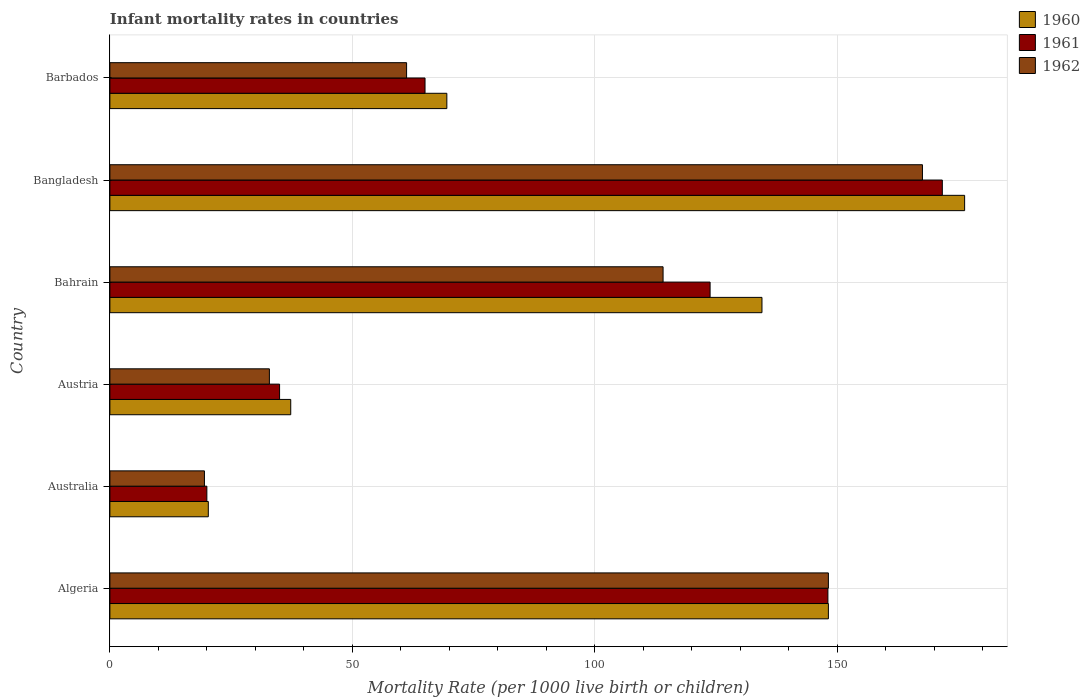Are the number of bars on each tick of the Y-axis equal?
Keep it short and to the point. Yes. What is the label of the 3rd group of bars from the top?
Offer a very short reply. Bahrain. What is the infant mortality rate in 1962 in Austria?
Your answer should be compact. 32.9. Across all countries, what is the maximum infant mortality rate in 1962?
Offer a terse response. 167.6. In which country was the infant mortality rate in 1960 minimum?
Your answer should be compact. Australia. What is the total infant mortality rate in 1960 in the graph?
Provide a succinct answer. 586.1. What is the difference between the infant mortality rate in 1960 in Algeria and that in Bangladesh?
Your answer should be very brief. -28.1. What is the difference between the infant mortality rate in 1962 in Barbados and the infant mortality rate in 1961 in Australia?
Give a very brief answer. 41.2. What is the average infant mortality rate in 1962 per country?
Provide a short and direct response. 90.58. What is the difference between the infant mortality rate in 1960 and infant mortality rate in 1961 in Austria?
Make the answer very short. 2.3. What is the ratio of the infant mortality rate in 1960 in Australia to that in Barbados?
Your answer should be very brief. 0.29. What is the difference between the highest and the second highest infant mortality rate in 1961?
Provide a short and direct response. 23.6. What is the difference between the highest and the lowest infant mortality rate in 1962?
Your response must be concise. 148.1. Is the sum of the infant mortality rate in 1960 in Algeria and Barbados greater than the maximum infant mortality rate in 1961 across all countries?
Your response must be concise. Yes. What does the 1st bar from the top in Bangladesh represents?
Offer a terse response. 1962. Is it the case that in every country, the sum of the infant mortality rate in 1961 and infant mortality rate in 1960 is greater than the infant mortality rate in 1962?
Make the answer very short. Yes. What is the difference between two consecutive major ticks on the X-axis?
Make the answer very short. 50. Are the values on the major ticks of X-axis written in scientific E-notation?
Keep it short and to the point. No. Does the graph contain any zero values?
Offer a very short reply. No. Does the graph contain grids?
Your answer should be very brief. Yes. How are the legend labels stacked?
Make the answer very short. Vertical. What is the title of the graph?
Your answer should be very brief. Infant mortality rates in countries. What is the label or title of the X-axis?
Your response must be concise. Mortality Rate (per 1000 live birth or children). What is the Mortality Rate (per 1000 live birth or children) in 1960 in Algeria?
Your answer should be very brief. 148.2. What is the Mortality Rate (per 1000 live birth or children) in 1961 in Algeria?
Your response must be concise. 148.1. What is the Mortality Rate (per 1000 live birth or children) of 1962 in Algeria?
Your answer should be very brief. 148.2. What is the Mortality Rate (per 1000 live birth or children) of 1960 in Australia?
Offer a very short reply. 20.3. What is the Mortality Rate (per 1000 live birth or children) in 1961 in Australia?
Your answer should be very brief. 20. What is the Mortality Rate (per 1000 live birth or children) of 1962 in Australia?
Provide a succinct answer. 19.5. What is the Mortality Rate (per 1000 live birth or children) in 1960 in Austria?
Offer a terse response. 37.3. What is the Mortality Rate (per 1000 live birth or children) in 1961 in Austria?
Keep it short and to the point. 35. What is the Mortality Rate (per 1000 live birth or children) in 1962 in Austria?
Provide a succinct answer. 32.9. What is the Mortality Rate (per 1000 live birth or children) of 1960 in Bahrain?
Offer a terse response. 134.5. What is the Mortality Rate (per 1000 live birth or children) of 1961 in Bahrain?
Offer a terse response. 123.8. What is the Mortality Rate (per 1000 live birth or children) of 1962 in Bahrain?
Provide a succinct answer. 114.1. What is the Mortality Rate (per 1000 live birth or children) of 1960 in Bangladesh?
Provide a succinct answer. 176.3. What is the Mortality Rate (per 1000 live birth or children) of 1961 in Bangladesh?
Keep it short and to the point. 171.7. What is the Mortality Rate (per 1000 live birth or children) of 1962 in Bangladesh?
Make the answer very short. 167.6. What is the Mortality Rate (per 1000 live birth or children) in 1960 in Barbados?
Keep it short and to the point. 69.5. What is the Mortality Rate (per 1000 live birth or children) of 1961 in Barbados?
Your answer should be compact. 65. What is the Mortality Rate (per 1000 live birth or children) in 1962 in Barbados?
Provide a succinct answer. 61.2. Across all countries, what is the maximum Mortality Rate (per 1000 live birth or children) in 1960?
Make the answer very short. 176.3. Across all countries, what is the maximum Mortality Rate (per 1000 live birth or children) of 1961?
Your answer should be very brief. 171.7. Across all countries, what is the maximum Mortality Rate (per 1000 live birth or children) in 1962?
Provide a short and direct response. 167.6. Across all countries, what is the minimum Mortality Rate (per 1000 live birth or children) of 1960?
Your response must be concise. 20.3. Across all countries, what is the minimum Mortality Rate (per 1000 live birth or children) in 1961?
Provide a succinct answer. 20. Across all countries, what is the minimum Mortality Rate (per 1000 live birth or children) of 1962?
Offer a very short reply. 19.5. What is the total Mortality Rate (per 1000 live birth or children) in 1960 in the graph?
Offer a terse response. 586.1. What is the total Mortality Rate (per 1000 live birth or children) of 1961 in the graph?
Offer a very short reply. 563.6. What is the total Mortality Rate (per 1000 live birth or children) in 1962 in the graph?
Your answer should be very brief. 543.5. What is the difference between the Mortality Rate (per 1000 live birth or children) of 1960 in Algeria and that in Australia?
Your answer should be compact. 127.9. What is the difference between the Mortality Rate (per 1000 live birth or children) in 1961 in Algeria and that in Australia?
Provide a short and direct response. 128.1. What is the difference between the Mortality Rate (per 1000 live birth or children) in 1962 in Algeria and that in Australia?
Make the answer very short. 128.7. What is the difference between the Mortality Rate (per 1000 live birth or children) in 1960 in Algeria and that in Austria?
Provide a short and direct response. 110.9. What is the difference between the Mortality Rate (per 1000 live birth or children) in 1961 in Algeria and that in Austria?
Your response must be concise. 113.1. What is the difference between the Mortality Rate (per 1000 live birth or children) in 1962 in Algeria and that in Austria?
Your response must be concise. 115.3. What is the difference between the Mortality Rate (per 1000 live birth or children) of 1961 in Algeria and that in Bahrain?
Your answer should be very brief. 24.3. What is the difference between the Mortality Rate (per 1000 live birth or children) of 1962 in Algeria and that in Bahrain?
Keep it short and to the point. 34.1. What is the difference between the Mortality Rate (per 1000 live birth or children) in 1960 in Algeria and that in Bangladesh?
Provide a succinct answer. -28.1. What is the difference between the Mortality Rate (per 1000 live birth or children) of 1961 in Algeria and that in Bangladesh?
Your answer should be compact. -23.6. What is the difference between the Mortality Rate (per 1000 live birth or children) in 1962 in Algeria and that in Bangladesh?
Ensure brevity in your answer.  -19.4. What is the difference between the Mortality Rate (per 1000 live birth or children) of 1960 in Algeria and that in Barbados?
Make the answer very short. 78.7. What is the difference between the Mortality Rate (per 1000 live birth or children) of 1961 in Algeria and that in Barbados?
Provide a succinct answer. 83.1. What is the difference between the Mortality Rate (per 1000 live birth or children) of 1962 in Australia and that in Austria?
Make the answer very short. -13.4. What is the difference between the Mortality Rate (per 1000 live birth or children) of 1960 in Australia and that in Bahrain?
Ensure brevity in your answer.  -114.2. What is the difference between the Mortality Rate (per 1000 live birth or children) in 1961 in Australia and that in Bahrain?
Ensure brevity in your answer.  -103.8. What is the difference between the Mortality Rate (per 1000 live birth or children) in 1962 in Australia and that in Bahrain?
Make the answer very short. -94.6. What is the difference between the Mortality Rate (per 1000 live birth or children) of 1960 in Australia and that in Bangladesh?
Offer a very short reply. -156. What is the difference between the Mortality Rate (per 1000 live birth or children) of 1961 in Australia and that in Bangladesh?
Ensure brevity in your answer.  -151.7. What is the difference between the Mortality Rate (per 1000 live birth or children) of 1962 in Australia and that in Bangladesh?
Provide a short and direct response. -148.1. What is the difference between the Mortality Rate (per 1000 live birth or children) of 1960 in Australia and that in Barbados?
Provide a succinct answer. -49.2. What is the difference between the Mortality Rate (per 1000 live birth or children) of 1961 in Australia and that in Barbados?
Give a very brief answer. -45. What is the difference between the Mortality Rate (per 1000 live birth or children) in 1962 in Australia and that in Barbados?
Provide a succinct answer. -41.7. What is the difference between the Mortality Rate (per 1000 live birth or children) in 1960 in Austria and that in Bahrain?
Your answer should be very brief. -97.2. What is the difference between the Mortality Rate (per 1000 live birth or children) in 1961 in Austria and that in Bahrain?
Your response must be concise. -88.8. What is the difference between the Mortality Rate (per 1000 live birth or children) of 1962 in Austria and that in Bahrain?
Make the answer very short. -81.2. What is the difference between the Mortality Rate (per 1000 live birth or children) of 1960 in Austria and that in Bangladesh?
Offer a terse response. -139. What is the difference between the Mortality Rate (per 1000 live birth or children) in 1961 in Austria and that in Bangladesh?
Provide a short and direct response. -136.7. What is the difference between the Mortality Rate (per 1000 live birth or children) of 1962 in Austria and that in Bangladesh?
Provide a short and direct response. -134.7. What is the difference between the Mortality Rate (per 1000 live birth or children) in 1960 in Austria and that in Barbados?
Your answer should be very brief. -32.2. What is the difference between the Mortality Rate (per 1000 live birth or children) of 1962 in Austria and that in Barbados?
Your answer should be very brief. -28.3. What is the difference between the Mortality Rate (per 1000 live birth or children) in 1960 in Bahrain and that in Bangladesh?
Make the answer very short. -41.8. What is the difference between the Mortality Rate (per 1000 live birth or children) in 1961 in Bahrain and that in Bangladesh?
Keep it short and to the point. -47.9. What is the difference between the Mortality Rate (per 1000 live birth or children) in 1962 in Bahrain and that in Bangladesh?
Ensure brevity in your answer.  -53.5. What is the difference between the Mortality Rate (per 1000 live birth or children) of 1960 in Bahrain and that in Barbados?
Your answer should be compact. 65. What is the difference between the Mortality Rate (per 1000 live birth or children) of 1961 in Bahrain and that in Barbados?
Your answer should be compact. 58.8. What is the difference between the Mortality Rate (per 1000 live birth or children) in 1962 in Bahrain and that in Barbados?
Your response must be concise. 52.9. What is the difference between the Mortality Rate (per 1000 live birth or children) in 1960 in Bangladesh and that in Barbados?
Your response must be concise. 106.8. What is the difference between the Mortality Rate (per 1000 live birth or children) of 1961 in Bangladesh and that in Barbados?
Provide a succinct answer. 106.7. What is the difference between the Mortality Rate (per 1000 live birth or children) of 1962 in Bangladesh and that in Barbados?
Your answer should be very brief. 106.4. What is the difference between the Mortality Rate (per 1000 live birth or children) in 1960 in Algeria and the Mortality Rate (per 1000 live birth or children) in 1961 in Australia?
Provide a short and direct response. 128.2. What is the difference between the Mortality Rate (per 1000 live birth or children) of 1960 in Algeria and the Mortality Rate (per 1000 live birth or children) of 1962 in Australia?
Your answer should be compact. 128.7. What is the difference between the Mortality Rate (per 1000 live birth or children) in 1961 in Algeria and the Mortality Rate (per 1000 live birth or children) in 1962 in Australia?
Give a very brief answer. 128.6. What is the difference between the Mortality Rate (per 1000 live birth or children) in 1960 in Algeria and the Mortality Rate (per 1000 live birth or children) in 1961 in Austria?
Make the answer very short. 113.2. What is the difference between the Mortality Rate (per 1000 live birth or children) in 1960 in Algeria and the Mortality Rate (per 1000 live birth or children) in 1962 in Austria?
Make the answer very short. 115.3. What is the difference between the Mortality Rate (per 1000 live birth or children) in 1961 in Algeria and the Mortality Rate (per 1000 live birth or children) in 1962 in Austria?
Make the answer very short. 115.2. What is the difference between the Mortality Rate (per 1000 live birth or children) in 1960 in Algeria and the Mortality Rate (per 1000 live birth or children) in 1961 in Bahrain?
Offer a very short reply. 24.4. What is the difference between the Mortality Rate (per 1000 live birth or children) in 1960 in Algeria and the Mortality Rate (per 1000 live birth or children) in 1962 in Bahrain?
Offer a terse response. 34.1. What is the difference between the Mortality Rate (per 1000 live birth or children) of 1960 in Algeria and the Mortality Rate (per 1000 live birth or children) of 1961 in Bangladesh?
Your answer should be very brief. -23.5. What is the difference between the Mortality Rate (per 1000 live birth or children) in 1960 in Algeria and the Mortality Rate (per 1000 live birth or children) in 1962 in Bangladesh?
Make the answer very short. -19.4. What is the difference between the Mortality Rate (per 1000 live birth or children) of 1961 in Algeria and the Mortality Rate (per 1000 live birth or children) of 1962 in Bangladesh?
Your response must be concise. -19.5. What is the difference between the Mortality Rate (per 1000 live birth or children) in 1960 in Algeria and the Mortality Rate (per 1000 live birth or children) in 1961 in Barbados?
Give a very brief answer. 83.2. What is the difference between the Mortality Rate (per 1000 live birth or children) in 1961 in Algeria and the Mortality Rate (per 1000 live birth or children) in 1962 in Barbados?
Offer a very short reply. 86.9. What is the difference between the Mortality Rate (per 1000 live birth or children) of 1960 in Australia and the Mortality Rate (per 1000 live birth or children) of 1961 in Austria?
Make the answer very short. -14.7. What is the difference between the Mortality Rate (per 1000 live birth or children) of 1960 in Australia and the Mortality Rate (per 1000 live birth or children) of 1962 in Austria?
Provide a succinct answer. -12.6. What is the difference between the Mortality Rate (per 1000 live birth or children) in 1960 in Australia and the Mortality Rate (per 1000 live birth or children) in 1961 in Bahrain?
Your response must be concise. -103.5. What is the difference between the Mortality Rate (per 1000 live birth or children) in 1960 in Australia and the Mortality Rate (per 1000 live birth or children) in 1962 in Bahrain?
Your answer should be very brief. -93.8. What is the difference between the Mortality Rate (per 1000 live birth or children) in 1961 in Australia and the Mortality Rate (per 1000 live birth or children) in 1962 in Bahrain?
Ensure brevity in your answer.  -94.1. What is the difference between the Mortality Rate (per 1000 live birth or children) of 1960 in Australia and the Mortality Rate (per 1000 live birth or children) of 1961 in Bangladesh?
Your response must be concise. -151.4. What is the difference between the Mortality Rate (per 1000 live birth or children) of 1960 in Australia and the Mortality Rate (per 1000 live birth or children) of 1962 in Bangladesh?
Ensure brevity in your answer.  -147.3. What is the difference between the Mortality Rate (per 1000 live birth or children) in 1961 in Australia and the Mortality Rate (per 1000 live birth or children) in 1962 in Bangladesh?
Your answer should be very brief. -147.6. What is the difference between the Mortality Rate (per 1000 live birth or children) of 1960 in Australia and the Mortality Rate (per 1000 live birth or children) of 1961 in Barbados?
Your answer should be compact. -44.7. What is the difference between the Mortality Rate (per 1000 live birth or children) of 1960 in Australia and the Mortality Rate (per 1000 live birth or children) of 1962 in Barbados?
Ensure brevity in your answer.  -40.9. What is the difference between the Mortality Rate (per 1000 live birth or children) in 1961 in Australia and the Mortality Rate (per 1000 live birth or children) in 1962 in Barbados?
Your answer should be compact. -41.2. What is the difference between the Mortality Rate (per 1000 live birth or children) in 1960 in Austria and the Mortality Rate (per 1000 live birth or children) in 1961 in Bahrain?
Offer a very short reply. -86.5. What is the difference between the Mortality Rate (per 1000 live birth or children) of 1960 in Austria and the Mortality Rate (per 1000 live birth or children) of 1962 in Bahrain?
Offer a terse response. -76.8. What is the difference between the Mortality Rate (per 1000 live birth or children) of 1961 in Austria and the Mortality Rate (per 1000 live birth or children) of 1962 in Bahrain?
Give a very brief answer. -79.1. What is the difference between the Mortality Rate (per 1000 live birth or children) in 1960 in Austria and the Mortality Rate (per 1000 live birth or children) in 1961 in Bangladesh?
Offer a terse response. -134.4. What is the difference between the Mortality Rate (per 1000 live birth or children) of 1960 in Austria and the Mortality Rate (per 1000 live birth or children) of 1962 in Bangladesh?
Ensure brevity in your answer.  -130.3. What is the difference between the Mortality Rate (per 1000 live birth or children) in 1961 in Austria and the Mortality Rate (per 1000 live birth or children) in 1962 in Bangladesh?
Give a very brief answer. -132.6. What is the difference between the Mortality Rate (per 1000 live birth or children) in 1960 in Austria and the Mortality Rate (per 1000 live birth or children) in 1961 in Barbados?
Make the answer very short. -27.7. What is the difference between the Mortality Rate (per 1000 live birth or children) in 1960 in Austria and the Mortality Rate (per 1000 live birth or children) in 1962 in Barbados?
Your answer should be very brief. -23.9. What is the difference between the Mortality Rate (per 1000 live birth or children) of 1961 in Austria and the Mortality Rate (per 1000 live birth or children) of 1962 in Barbados?
Ensure brevity in your answer.  -26.2. What is the difference between the Mortality Rate (per 1000 live birth or children) of 1960 in Bahrain and the Mortality Rate (per 1000 live birth or children) of 1961 in Bangladesh?
Ensure brevity in your answer.  -37.2. What is the difference between the Mortality Rate (per 1000 live birth or children) in 1960 in Bahrain and the Mortality Rate (per 1000 live birth or children) in 1962 in Bangladesh?
Your answer should be compact. -33.1. What is the difference between the Mortality Rate (per 1000 live birth or children) in 1961 in Bahrain and the Mortality Rate (per 1000 live birth or children) in 1962 in Bangladesh?
Offer a terse response. -43.8. What is the difference between the Mortality Rate (per 1000 live birth or children) in 1960 in Bahrain and the Mortality Rate (per 1000 live birth or children) in 1961 in Barbados?
Give a very brief answer. 69.5. What is the difference between the Mortality Rate (per 1000 live birth or children) in 1960 in Bahrain and the Mortality Rate (per 1000 live birth or children) in 1962 in Barbados?
Offer a very short reply. 73.3. What is the difference between the Mortality Rate (per 1000 live birth or children) of 1961 in Bahrain and the Mortality Rate (per 1000 live birth or children) of 1962 in Barbados?
Offer a very short reply. 62.6. What is the difference between the Mortality Rate (per 1000 live birth or children) in 1960 in Bangladesh and the Mortality Rate (per 1000 live birth or children) in 1961 in Barbados?
Give a very brief answer. 111.3. What is the difference between the Mortality Rate (per 1000 live birth or children) of 1960 in Bangladesh and the Mortality Rate (per 1000 live birth or children) of 1962 in Barbados?
Make the answer very short. 115.1. What is the difference between the Mortality Rate (per 1000 live birth or children) in 1961 in Bangladesh and the Mortality Rate (per 1000 live birth or children) in 1962 in Barbados?
Your answer should be very brief. 110.5. What is the average Mortality Rate (per 1000 live birth or children) in 1960 per country?
Provide a short and direct response. 97.68. What is the average Mortality Rate (per 1000 live birth or children) in 1961 per country?
Make the answer very short. 93.93. What is the average Mortality Rate (per 1000 live birth or children) of 1962 per country?
Keep it short and to the point. 90.58. What is the difference between the Mortality Rate (per 1000 live birth or children) in 1960 and Mortality Rate (per 1000 live birth or children) in 1961 in Algeria?
Provide a short and direct response. 0.1. What is the difference between the Mortality Rate (per 1000 live birth or children) in 1960 and Mortality Rate (per 1000 live birth or children) in 1962 in Algeria?
Your answer should be very brief. 0. What is the difference between the Mortality Rate (per 1000 live birth or children) in 1960 and Mortality Rate (per 1000 live birth or children) in 1961 in Australia?
Give a very brief answer. 0.3. What is the difference between the Mortality Rate (per 1000 live birth or children) in 1960 and Mortality Rate (per 1000 live birth or children) in 1962 in Australia?
Ensure brevity in your answer.  0.8. What is the difference between the Mortality Rate (per 1000 live birth or children) of 1960 and Mortality Rate (per 1000 live birth or children) of 1961 in Austria?
Provide a succinct answer. 2.3. What is the difference between the Mortality Rate (per 1000 live birth or children) of 1961 and Mortality Rate (per 1000 live birth or children) of 1962 in Austria?
Offer a terse response. 2.1. What is the difference between the Mortality Rate (per 1000 live birth or children) of 1960 and Mortality Rate (per 1000 live birth or children) of 1962 in Bahrain?
Provide a short and direct response. 20.4. What is the difference between the Mortality Rate (per 1000 live birth or children) in 1960 and Mortality Rate (per 1000 live birth or children) in 1961 in Bangladesh?
Provide a succinct answer. 4.6. What is the difference between the Mortality Rate (per 1000 live birth or children) of 1960 and Mortality Rate (per 1000 live birth or children) of 1962 in Bangladesh?
Offer a terse response. 8.7. What is the difference between the Mortality Rate (per 1000 live birth or children) of 1960 and Mortality Rate (per 1000 live birth or children) of 1962 in Barbados?
Your answer should be very brief. 8.3. What is the ratio of the Mortality Rate (per 1000 live birth or children) in 1960 in Algeria to that in Australia?
Your response must be concise. 7.3. What is the ratio of the Mortality Rate (per 1000 live birth or children) in 1961 in Algeria to that in Australia?
Give a very brief answer. 7.41. What is the ratio of the Mortality Rate (per 1000 live birth or children) of 1960 in Algeria to that in Austria?
Your answer should be very brief. 3.97. What is the ratio of the Mortality Rate (per 1000 live birth or children) of 1961 in Algeria to that in Austria?
Make the answer very short. 4.23. What is the ratio of the Mortality Rate (per 1000 live birth or children) in 1962 in Algeria to that in Austria?
Keep it short and to the point. 4.5. What is the ratio of the Mortality Rate (per 1000 live birth or children) of 1960 in Algeria to that in Bahrain?
Provide a short and direct response. 1.1. What is the ratio of the Mortality Rate (per 1000 live birth or children) in 1961 in Algeria to that in Bahrain?
Provide a short and direct response. 1.2. What is the ratio of the Mortality Rate (per 1000 live birth or children) of 1962 in Algeria to that in Bahrain?
Ensure brevity in your answer.  1.3. What is the ratio of the Mortality Rate (per 1000 live birth or children) in 1960 in Algeria to that in Bangladesh?
Give a very brief answer. 0.84. What is the ratio of the Mortality Rate (per 1000 live birth or children) of 1961 in Algeria to that in Bangladesh?
Give a very brief answer. 0.86. What is the ratio of the Mortality Rate (per 1000 live birth or children) of 1962 in Algeria to that in Bangladesh?
Offer a very short reply. 0.88. What is the ratio of the Mortality Rate (per 1000 live birth or children) in 1960 in Algeria to that in Barbados?
Offer a terse response. 2.13. What is the ratio of the Mortality Rate (per 1000 live birth or children) of 1961 in Algeria to that in Barbados?
Make the answer very short. 2.28. What is the ratio of the Mortality Rate (per 1000 live birth or children) of 1962 in Algeria to that in Barbados?
Your answer should be very brief. 2.42. What is the ratio of the Mortality Rate (per 1000 live birth or children) in 1960 in Australia to that in Austria?
Keep it short and to the point. 0.54. What is the ratio of the Mortality Rate (per 1000 live birth or children) of 1962 in Australia to that in Austria?
Provide a succinct answer. 0.59. What is the ratio of the Mortality Rate (per 1000 live birth or children) of 1960 in Australia to that in Bahrain?
Offer a terse response. 0.15. What is the ratio of the Mortality Rate (per 1000 live birth or children) of 1961 in Australia to that in Bahrain?
Provide a succinct answer. 0.16. What is the ratio of the Mortality Rate (per 1000 live birth or children) in 1962 in Australia to that in Bahrain?
Make the answer very short. 0.17. What is the ratio of the Mortality Rate (per 1000 live birth or children) of 1960 in Australia to that in Bangladesh?
Provide a short and direct response. 0.12. What is the ratio of the Mortality Rate (per 1000 live birth or children) of 1961 in Australia to that in Bangladesh?
Your response must be concise. 0.12. What is the ratio of the Mortality Rate (per 1000 live birth or children) of 1962 in Australia to that in Bangladesh?
Your response must be concise. 0.12. What is the ratio of the Mortality Rate (per 1000 live birth or children) of 1960 in Australia to that in Barbados?
Make the answer very short. 0.29. What is the ratio of the Mortality Rate (per 1000 live birth or children) of 1961 in Australia to that in Barbados?
Your answer should be compact. 0.31. What is the ratio of the Mortality Rate (per 1000 live birth or children) in 1962 in Australia to that in Barbados?
Ensure brevity in your answer.  0.32. What is the ratio of the Mortality Rate (per 1000 live birth or children) in 1960 in Austria to that in Bahrain?
Keep it short and to the point. 0.28. What is the ratio of the Mortality Rate (per 1000 live birth or children) in 1961 in Austria to that in Bahrain?
Ensure brevity in your answer.  0.28. What is the ratio of the Mortality Rate (per 1000 live birth or children) of 1962 in Austria to that in Bahrain?
Your answer should be compact. 0.29. What is the ratio of the Mortality Rate (per 1000 live birth or children) in 1960 in Austria to that in Bangladesh?
Provide a short and direct response. 0.21. What is the ratio of the Mortality Rate (per 1000 live birth or children) in 1961 in Austria to that in Bangladesh?
Provide a short and direct response. 0.2. What is the ratio of the Mortality Rate (per 1000 live birth or children) in 1962 in Austria to that in Bangladesh?
Give a very brief answer. 0.2. What is the ratio of the Mortality Rate (per 1000 live birth or children) of 1960 in Austria to that in Barbados?
Ensure brevity in your answer.  0.54. What is the ratio of the Mortality Rate (per 1000 live birth or children) in 1961 in Austria to that in Barbados?
Your answer should be compact. 0.54. What is the ratio of the Mortality Rate (per 1000 live birth or children) of 1962 in Austria to that in Barbados?
Make the answer very short. 0.54. What is the ratio of the Mortality Rate (per 1000 live birth or children) in 1960 in Bahrain to that in Bangladesh?
Ensure brevity in your answer.  0.76. What is the ratio of the Mortality Rate (per 1000 live birth or children) of 1961 in Bahrain to that in Bangladesh?
Provide a short and direct response. 0.72. What is the ratio of the Mortality Rate (per 1000 live birth or children) in 1962 in Bahrain to that in Bangladesh?
Provide a short and direct response. 0.68. What is the ratio of the Mortality Rate (per 1000 live birth or children) in 1960 in Bahrain to that in Barbados?
Provide a succinct answer. 1.94. What is the ratio of the Mortality Rate (per 1000 live birth or children) of 1961 in Bahrain to that in Barbados?
Give a very brief answer. 1.9. What is the ratio of the Mortality Rate (per 1000 live birth or children) of 1962 in Bahrain to that in Barbados?
Provide a succinct answer. 1.86. What is the ratio of the Mortality Rate (per 1000 live birth or children) in 1960 in Bangladesh to that in Barbados?
Offer a terse response. 2.54. What is the ratio of the Mortality Rate (per 1000 live birth or children) in 1961 in Bangladesh to that in Barbados?
Offer a terse response. 2.64. What is the ratio of the Mortality Rate (per 1000 live birth or children) of 1962 in Bangladesh to that in Barbados?
Your answer should be compact. 2.74. What is the difference between the highest and the second highest Mortality Rate (per 1000 live birth or children) in 1960?
Offer a very short reply. 28.1. What is the difference between the highest and the second highest Mortality Rate (per 1000 live birth or children) of 1961?
Your response must be concise. 23.6. What is the difference between the highest and the lowest Mortality Rate (per 1000 live birth or children) of 1960?
Keep it short and to the point. 156. What is the difference between the highest and the lowest Mortality Rate (per 1000 live birth or children) in 1961?
Ensure brevity in your answer.  151.7. What is the difference between the highest and the lowest Mortality Rate (per 1000 live birth or children) in 1962?
Provide a short and direct response. 148.1. 